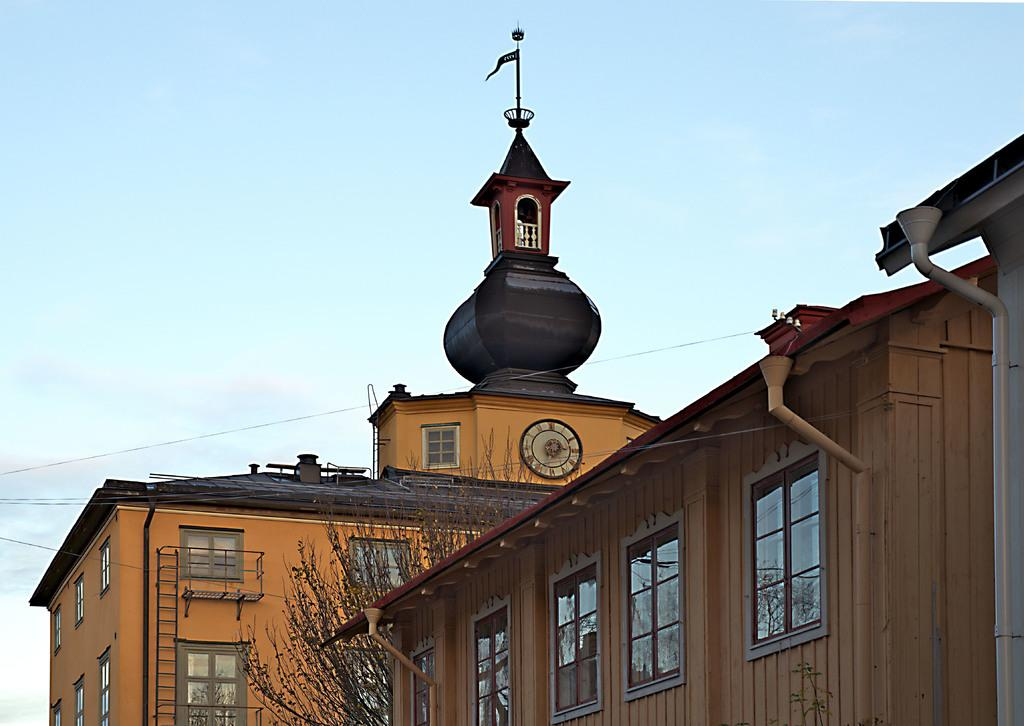What is the main subject in the center of the image? There are buildings in the center of the image. What can be seen at the top of the image? The sky is visible at the top of the image. What type of paper is being used to create the buildings in the image? There is no paper present in the image; the buildings are depicted using other artistic techniques or materials. 